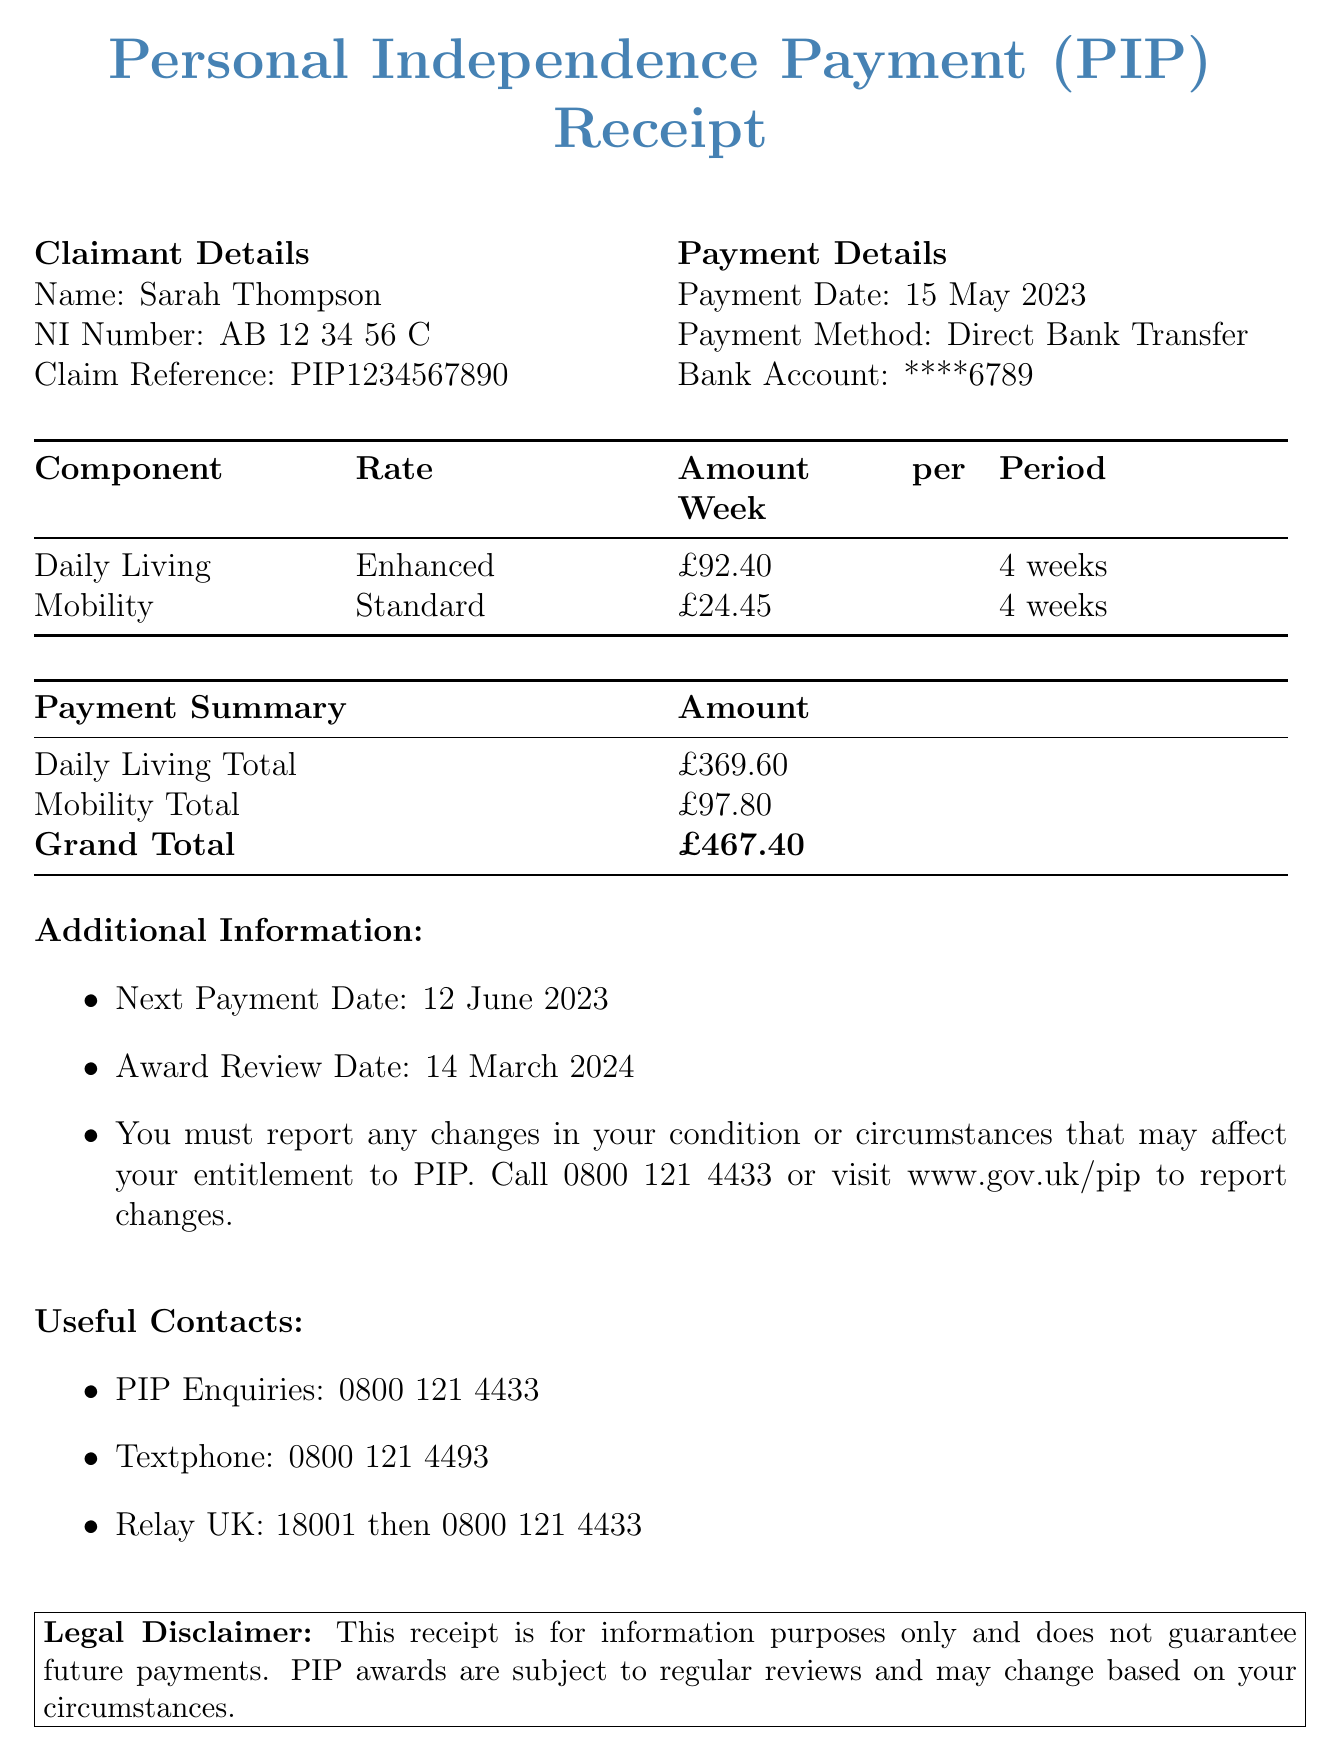What is the name of the claimant? The claimant's name is listed in the claimant details section of the document.
Answer: Sarah Thompson What is the payment date? The payment date is specified in the payment details section of the document.
Answer: 15 May 2023 What is the total amount for the daily living component? The total amount for the daily living component is listed in the payment summary section of the document.
Answer: £369.60 What payment method was used? The payment method is detailed in the payment details section of the document.
Answer: Direct Bank Transfer What will be the next payment date? The next payment date is found in the additional information section of the document.
Answer: 12 June 2023 What is the rate for the mobility component? The rate for the mobility component is clearly stated in the payment breakdown section of the document.
Answer: Standard What is the grand total amount received? The grand total amount is provided in the payment summary section, which combines the totals.
Answer: £467.40 When is the award review date? The award review date is given in the additional information section of the document.
Answer: 14 March 2024 What must be reported to the authority? The document indicates what needs to be reported in the additional information section.
Answer: Changes in your condition or circumstances 